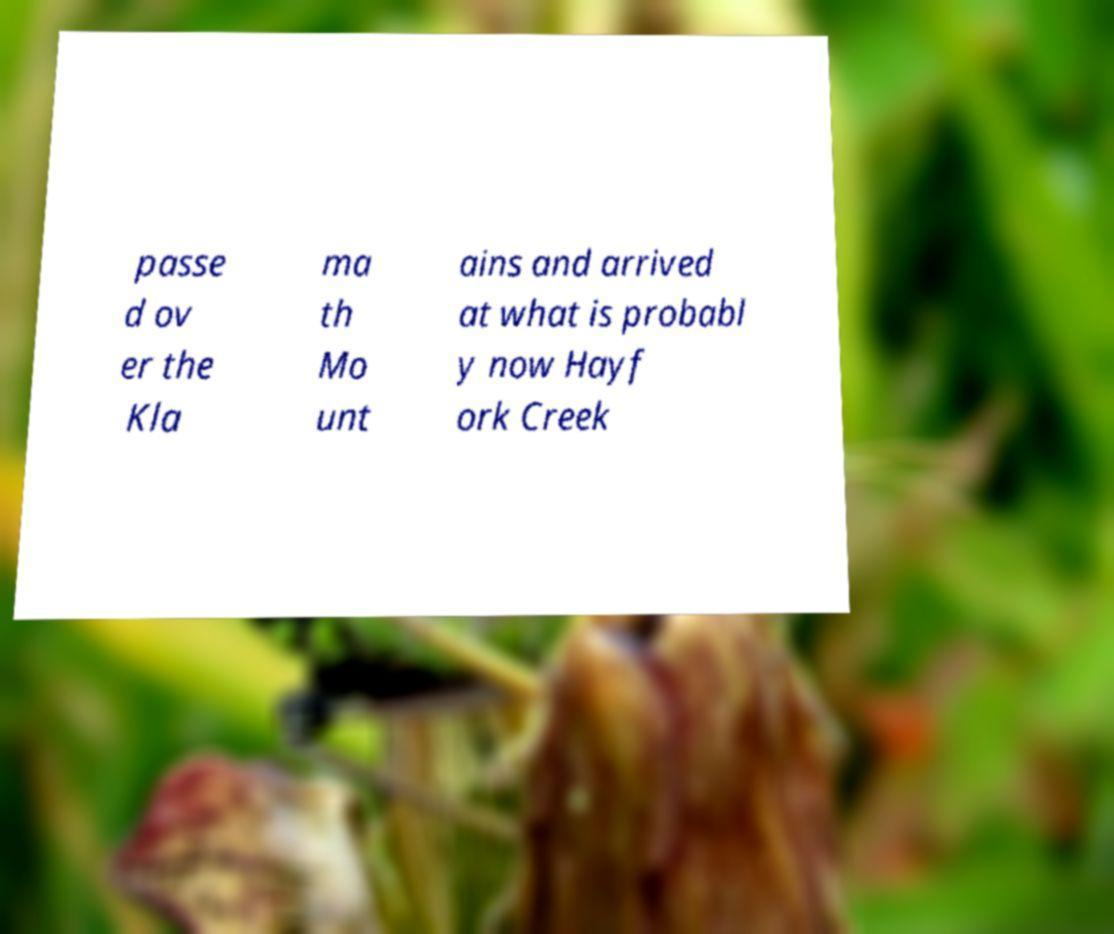What messages or text are displayed in this image? I need them in a readable, typed format. passe d ov er the Kla ma th Mo unt ains and arrived at what is probabl y now Hayf ork Creek 